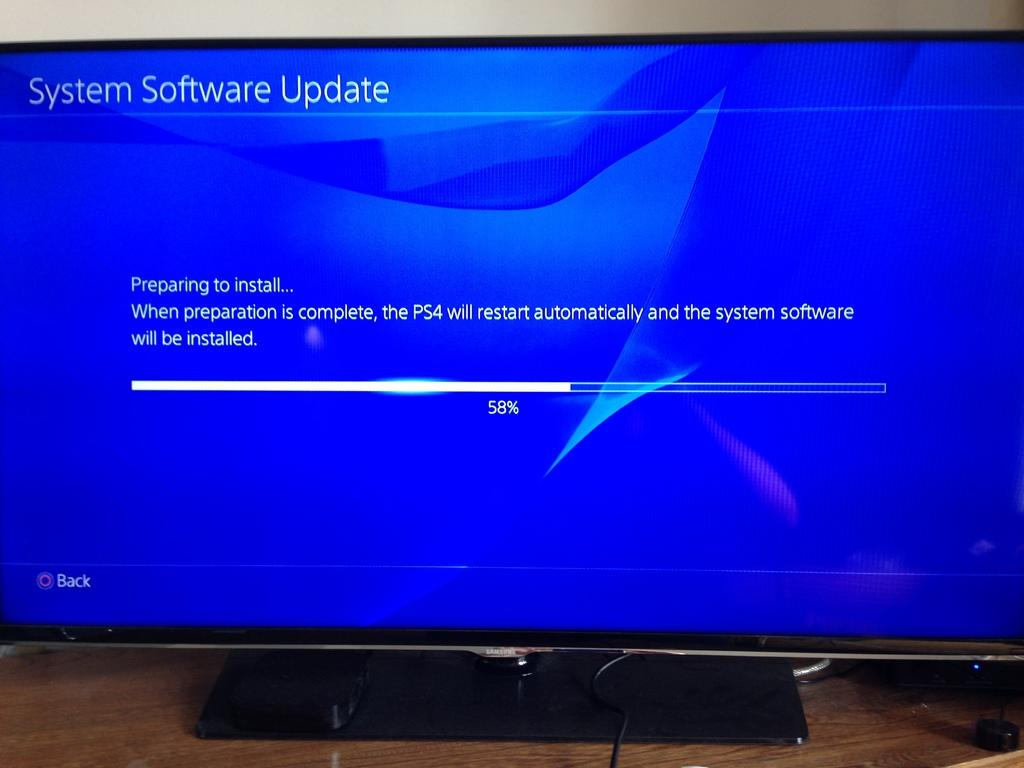<image>
Write a terse but informative summary of the picture. a computer monitor displaying the message of system software update 